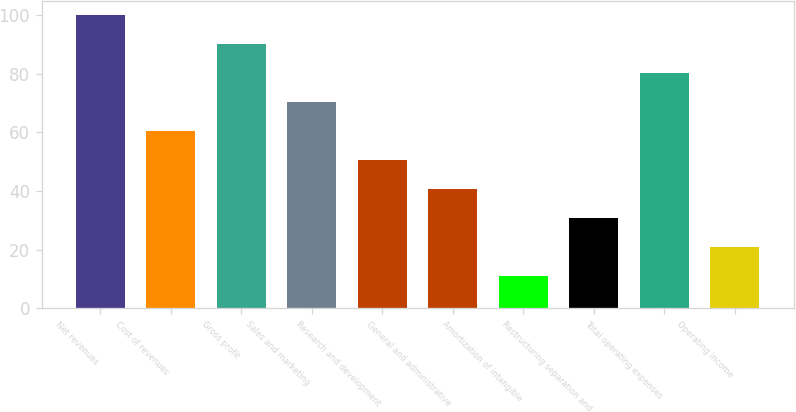Convert chart. <chart><loc_0><loc_0><loc_500><loc_500><bar_chart><fcel>Net revenues<fcel>Cost of revenues<fcel>Gross profit<fcel>Sales and marketing<fcel>Research and development<fcel>General and administrative<fcel>Amortization of intangible<fcel>Restructuring separation and<fcel>Total operating expenses<fcel>Operating income<nl><fcel>100<fcel>60.4<fcel>90.1<fcel>70.3<fcel>50.5<fcel>40.6<fcel>10.9<fcel>30.7<fcel>80.2<fcel>20.8<nl></chart> 